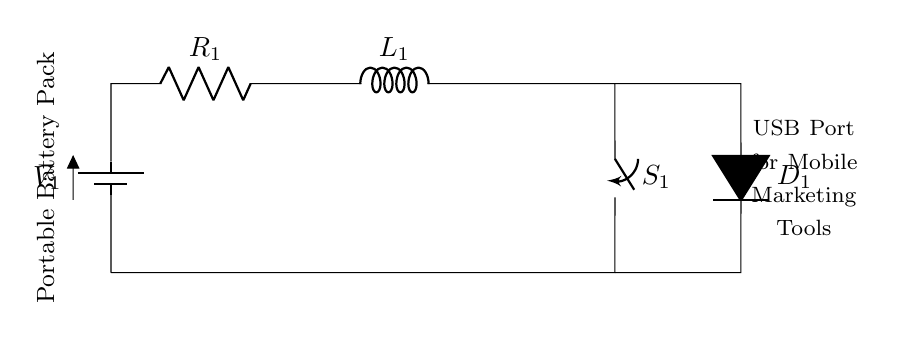What is the type of the circuit shown? The circuit is a series circuit, where all components are connected end-to-end in a single path for current to flow.
Answer: series circuit What component represents the power source? The component labeled as V1 indicates the battery, which provides the necessary power for the circuit.
Answer: battery What is the function of the switch in the circuit? The switch (labeled S1) serves to open or close the current path, allowing control over whether electrical flow to the components is enabled or disabled.
Answer: control How many resistive components are present in the circuit? There is one resistive component, which is labeled R1, indicating a resistor in the circuit.
Answer: one What component is used for current protection in the circuit? The component labeled D1 is a diode, which allows current to flow in one direction and protects the rest of the circuit from potential reverse voltage.
Answer: diode What is the function of the inductor in this circuit? The inductor (labeled L1) can store energy in the magnetic field when current passes through it and helps to smooth out fluctuations in current.
Answer: store energy What is the connection method for the USB port in this circuit? The USB port is connected in parallel to the battery and other components, allowing devices to draw power independently of the series circuit configuration.
Answer: parallel 